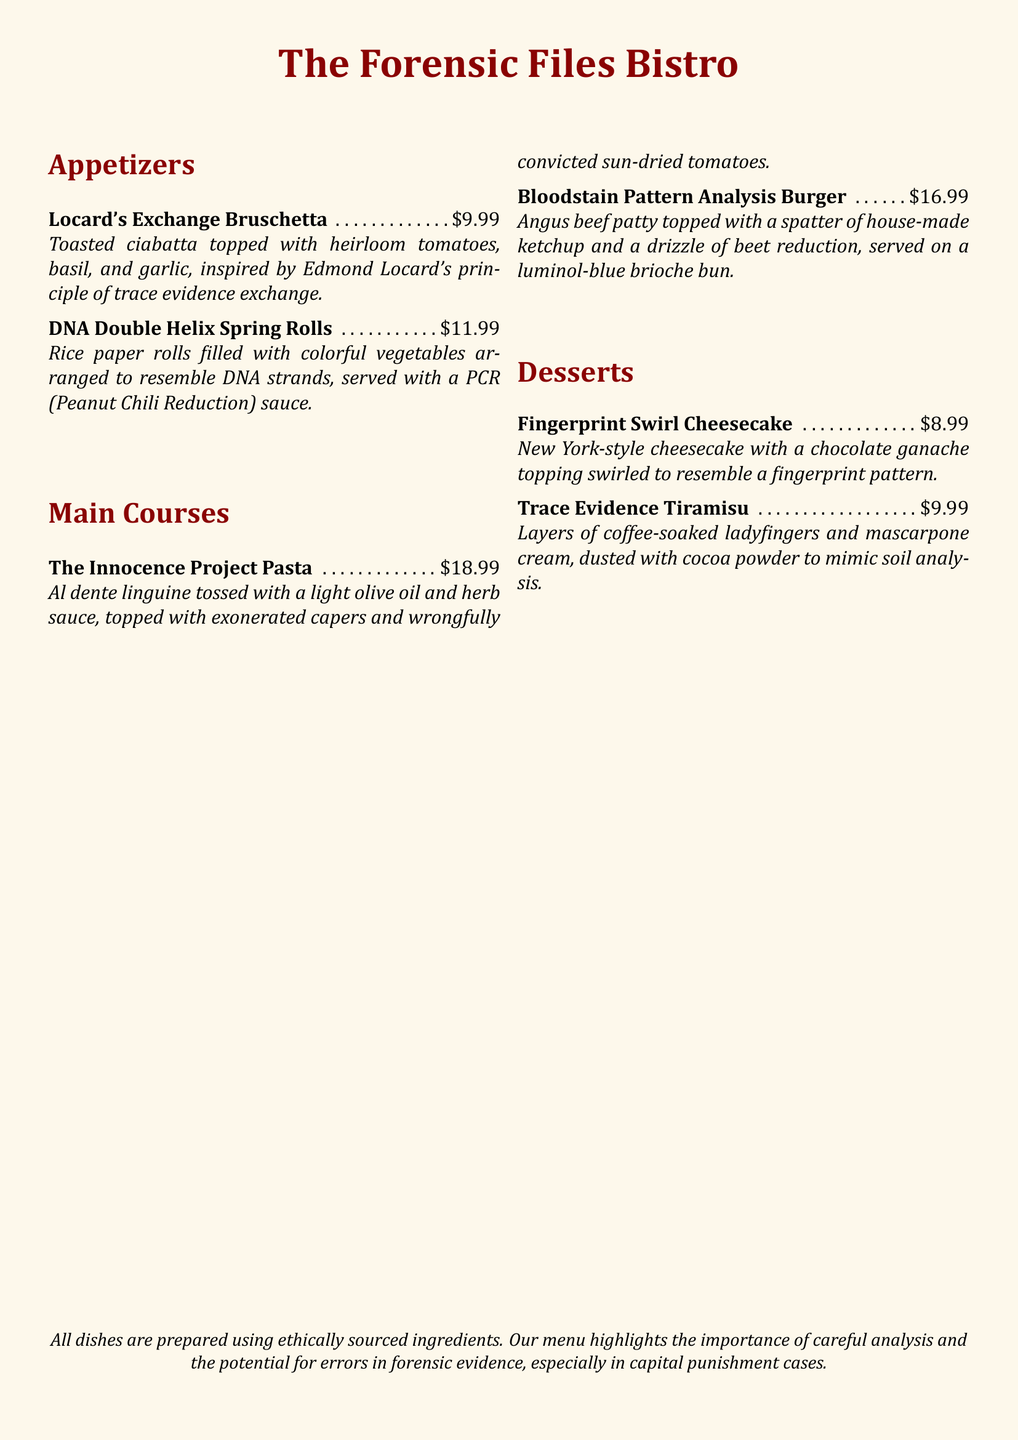What is the price of the Locard's Exchange Bruschetta? The price is listed directly next to the dish in the menu.
Answer: $9.99 What dish is inspired by the Innocence Project? The menu item specifically mentions it is inspired by the Innocence Project.
Answer: The Innocence Project Pasta How many appetizers are listed on the menu? The appetizers section contains two items.
Answer: 2 What color is the brioche bun in the Bloodstain Pattern Analysis Burger? The description indicates the color of the bun is given in the summary of the dish.
Answer: Luminol-blue What is the dessert that resembles a fingerprint? The dessert description explicitly refers to its resemblance to a fingerprint.
Answer: Fingerprint Swirl Cheesecake What ingredient is common to both spring rolls and tiramisu? Both dishes list a specific ingredient that is related to the theme present in their descriptions.
Answer: Coffee 